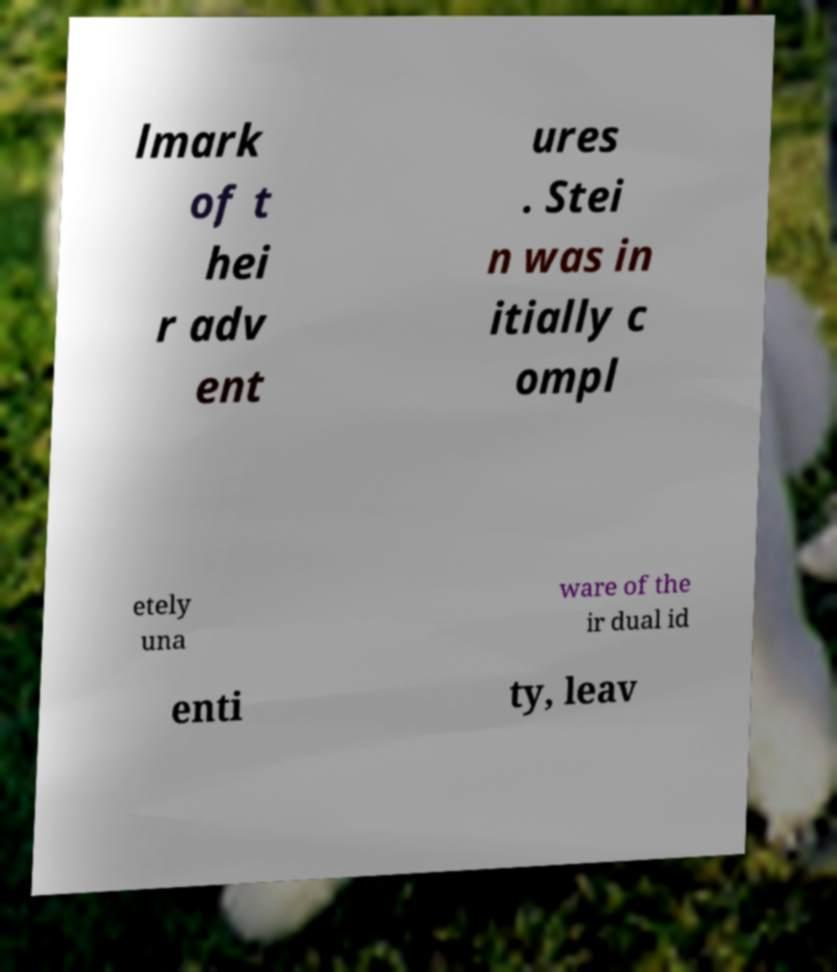There's text embedded in this image that I need extracted. Can you transcribe it verbatim? lmark of t hei r adv ent ures . Stei n was in itially c ompl etely una ware of the ir dual id enti ty, leav 